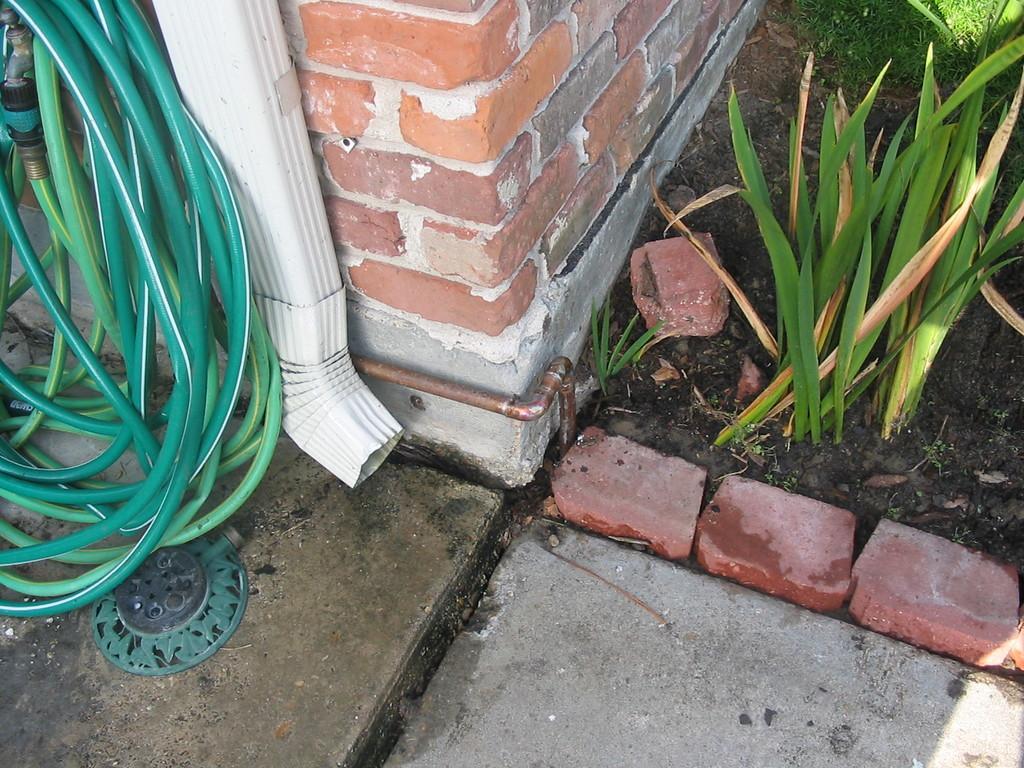In one or two sentences, can you explain what this image depicts? On the left side there is a water pipe in green color. On the right side there are plants, in the middle it is a brick wall. 